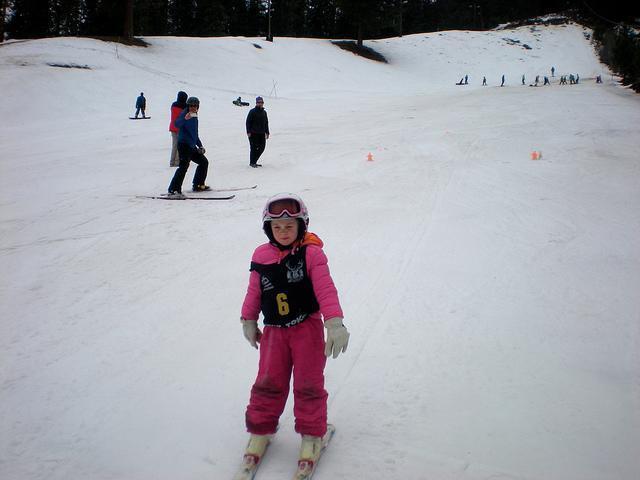How many people are visible?
Give a very brief answer. 2. 